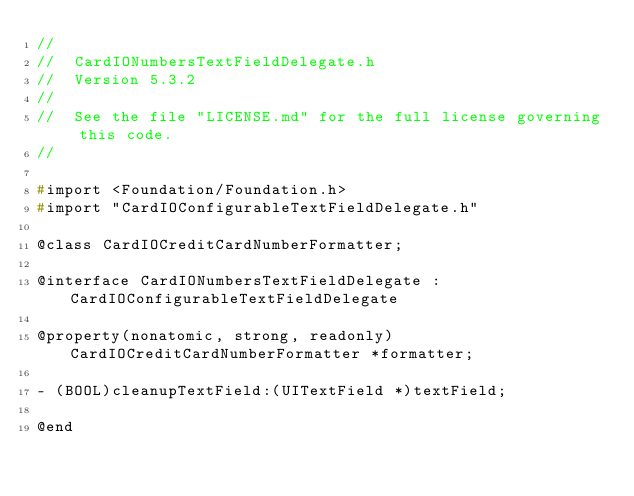<code> <loc_0><loc_0><loc_500><loc_500><_C_>//
//  CardIONumbersTextFieldDelegate.h
//  Version 5.3.2
//
//  See the file "LICENSE.md" for the full license governing this code.
//

#import <Foundation/Foundation.h>
#import "CardIOConfigurableTextFieldDelegate.h"

@class CardIOCreditCardNumberFormatter;

@interface CardIONumbersTextFieldDelegate : CardIOConfigurableTextFieldDelegate

@property(nonatomic, strong, readonly) CardIOCreditCardNumberFormatter *formatter;

- (BOOL)cleanupTextField:(UITextField *)textField;

@end</code> 